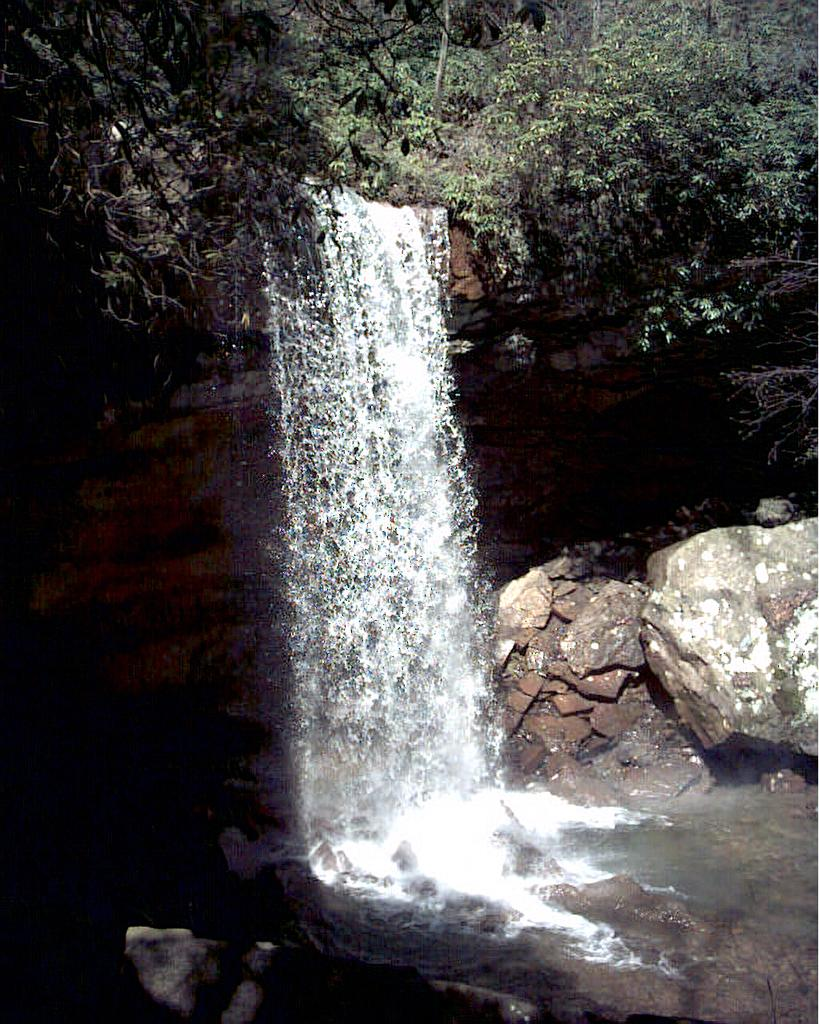What natural feature is the main subject of the image? There is a waterfall in the image. What can be seen on the right side of the image? There are many stones on the right side of the image. What type of vegetation is present at the top of the image? There are trees and plants at the top of the image. What type of glass is used to create the curve in the waterfall? There is no glass or curve present in the waterfall; it is a natural feature. 